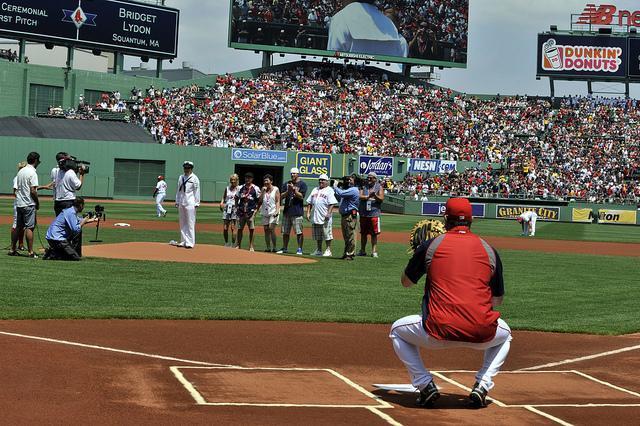How many people are in the photo?
Give a very brief answer. 2. 